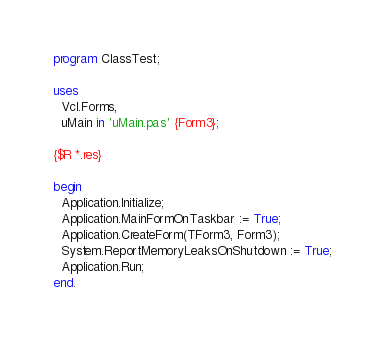Convert code to text. <code><loc_0><loc_0><loc_500><loc_500><_Pascal_>program ClassTest;

uses
  Vcl.Forms,
  uMain in 'uMain.pas' {Form3};

{$R *.res}

begin
  Application.Initialize;
  Application.MainFormOnTaskbar := True;
  Application.CreateForm(TForm3, Form3);
  System.ReportMemoryLeaksOnShutdown := True;
  Application.Run;
end.
</code> 